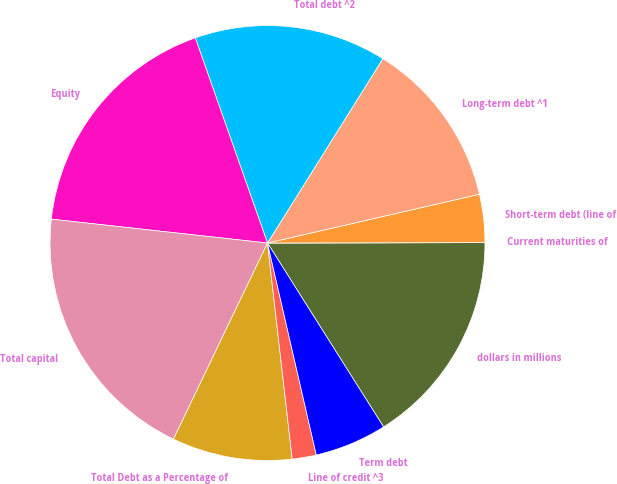Convert chart to OTSL. <chart><loc_0><loc_0><loc_500><loc_500><pie_chart><fcel>dollars in millions<fcel>Current maturities of<fcel>Short-term debt (line of<fcel>Long-term debt ^1<fcel>Total debt ^2<fcel>Equity<fcel>Total capital<fcel>Total Debt as a Percentage of<fcel>Line of credit ^3<fcel>Term debt<nl><fcel>16.07%<fcel>0.0%<fcel>3.57%<fcel>12.5%<fcel>14.29%<fcel>17.86%<fcel>19.64%<fcel>8.93%<fcel>1.79%<fcel>5.36%<nl></chart> 